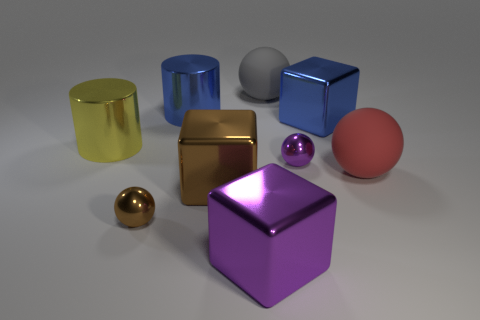Subtract all brown metal spheres. How many spheres are left? 3 Subtract all yellow cylinders. How many cylinders are left? 1 Subtract 1 blocks. How many blocks are left? 2 Add 1 large blue metallic cylinders. How many objects exist? 10 Subtract all gray blocks. Subtract all yellow balls. How many blocks are left? 3 Subtract all cubes. How many objects are left? 6 Add 5 blue metallic cylinders. How many blue metallic cylinders are left? 6 Add 8 blue cubes. How many blue cubes exist? 9 Subtract 0 yellow blocks. How many objects are left? 9 Subtract all cyan objects. Subtract all blue shiny cylinders. How many objects are left? 8 